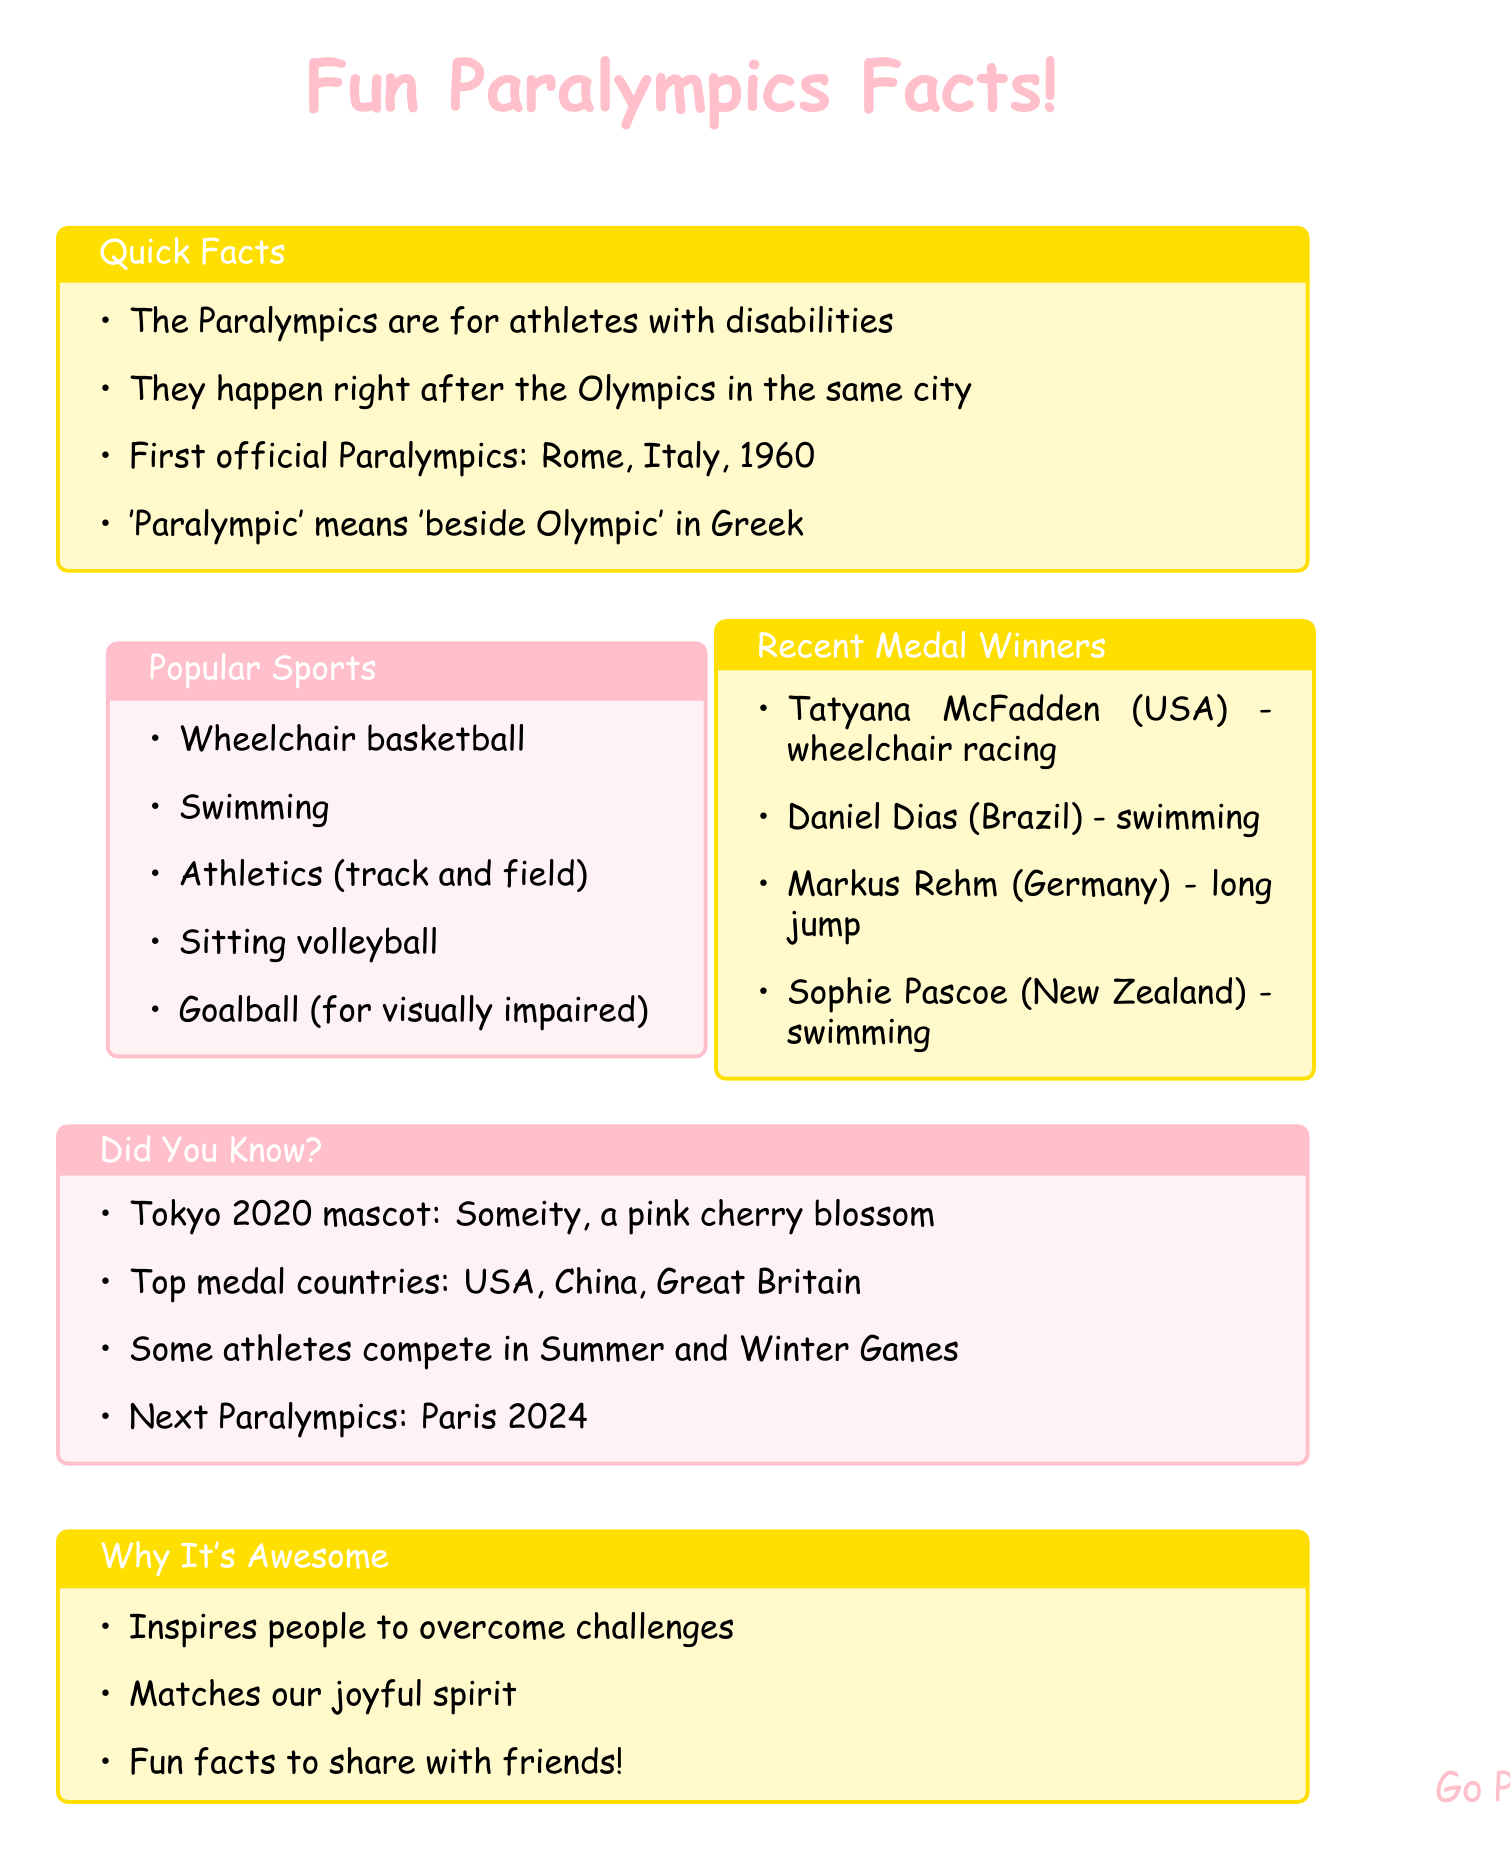What year were the first official Paralympics held? The document states that the first official Paralympics were in Rome, Italy in 1960.
Answer: 1960 What is the meaning of the word "Paralympic"? The document explains that "Paralympic" means "beside Olympic" in Greek.
Answer: beside Olympic Which country did Tatyana McFadden represent? The document mentions that Tatyana McFadden is from the USA.
Answer: USA What sport involves athletes competing in wheelchairs? The document lists wheelchair basketball as one of the popular sports.
Answer: wheelchair basketball Which city's Paralympics will take place in 2024? The document informs that the 2024 Paralympics will be held in Paris, France.
Answer: Paris Which countries are often top medal winners? The document lists USA, China, and Great Britain as top medal-winning countries.
Answer: USA, China, Great Britain Name one sport specifically designed for visually impaired athletes. The document describes goalball as a team sport for visually impaired athletes.
Answer: goalball What is the mascot for the Tokyo 2020 Paralympics? The document states that the mascot was Someity, a pink cherry blossom character.
Answer: Someity How do the Paralympics inspire people? The document emphasizes that they inspire people to overcome challenges.
Answer: to overcome challenges 